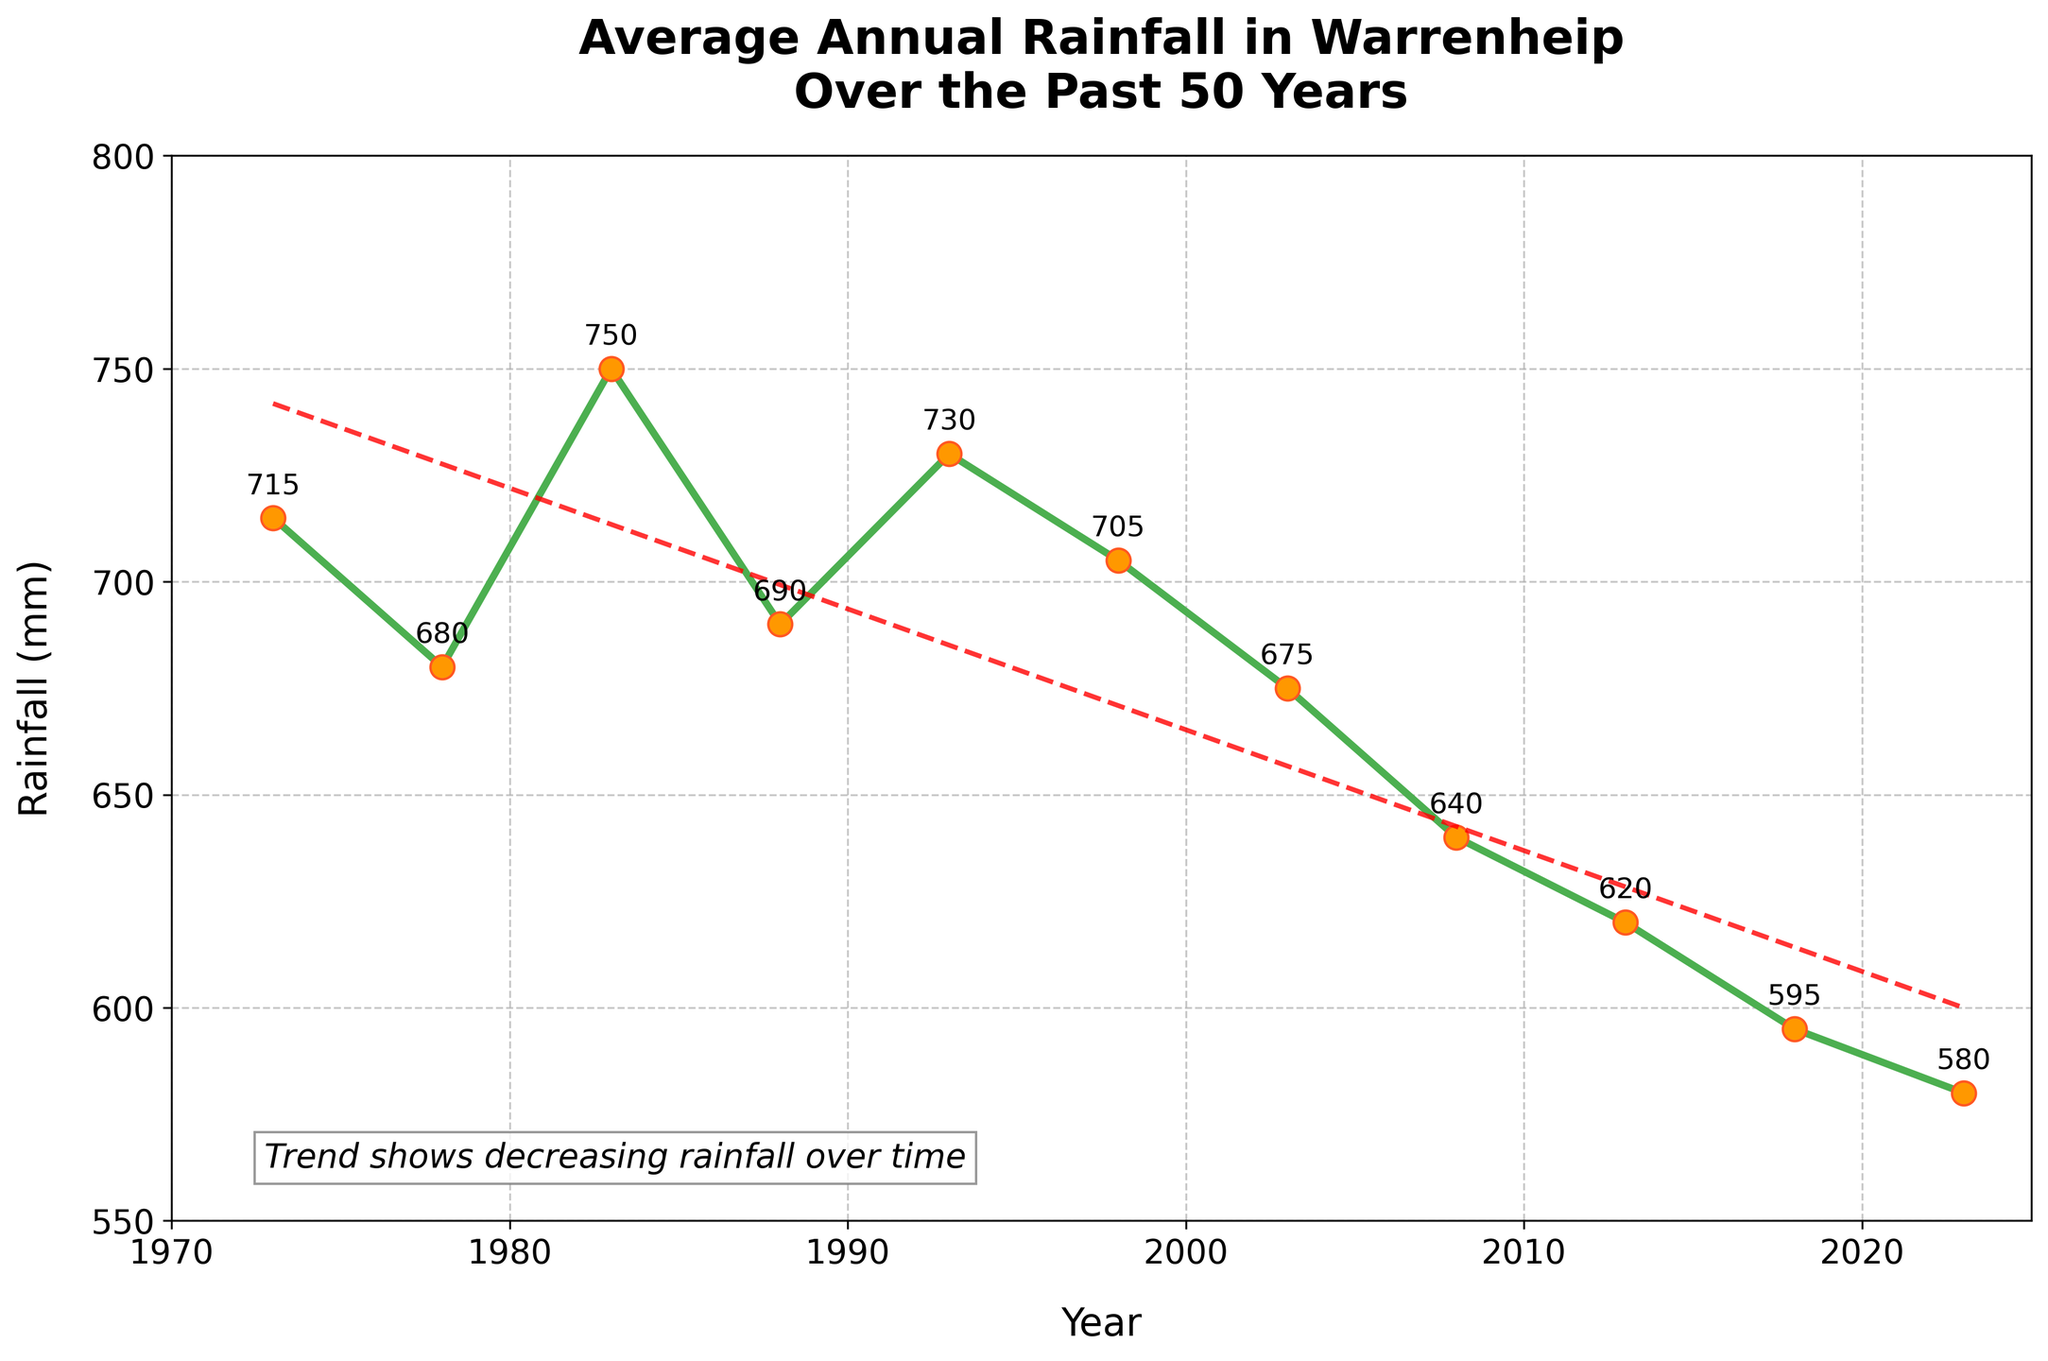What is the general trend of average annual rainfall in Warrenheip over the past 50 years? The plot shows a red dashed trend line that generally slopes downward from 1973 to 2023, indicating a decreasing trend in average annual rainfall.
Answer: Decreasing What is the highest recorded average annual rainfall in the dataset, and in which year was it observed? The highest point on the line plot is at 750 mm, which was recorded in the year 1983.
Answer: 750 mm in 1983 How much did the average annual rainfall decrease from 1973 to 2023? The rainfall in 1973 was 715 mm, and in 2023 it was 580 mm. The difference is 715 mm - 580 mm = 135 mm.
Answer: 135 mm Which year had the lowest average annual rainfall, and what was the value? The lowest point on the line plot is at 580 mm, which was recorded in the year 2023.
Answer: 580 mm in 2023 By how much did the average annual rainfall increase from 2013 to 2018? The rainfall in 2013 was 620 mm, and in 2018 it was 595 mm. The difference is 595 mm - 620 mm = -25 mm, indicating a decrease rather than an increase.
Answer: -25 mm (a decrease) What is the average annual rainfall over the last 50 years? There are 11 data points. Summing the values: 715 + 680 + 750 + 690 + 730 + 705 + 675 + 640 + 620 + 595 + 580 = 7380. Dividing by the number of data points: 7380 / 11 ≈ 670.91 mm.
Answer: 670.91 mm How does the average annual rainfall in 1993 compare to that in 1998? The rainfall in 1993 was 730 mm, and in 1998 it was 705 mm. Comparing them, 730 mm is greater than 705 mm.
Answer: 730 mm is greater What is the difference in average annual rainfall between the highest and lowest recorded years? The highest rainfall is 750 mm in 1983 and the lowest is 580 mm in 2023. The difference is 750 mm - 580 mm = 170 mm.
Answer: 170 mm How does the rainfall measurement in 2008 compare to the trend shown by the red dashed line? The rainfall in 2008 was 640 mm. The red dashed trend line is generally below this value in the years close to 2008, indicating that the 2008 rainfall was slightly above the trend line.
Answer: Slightly above the trend Identify two consecutive years where the average annual rainfall increased, and specify the increments. From 1978 (680 mm) to 1983 (750 mm), the rainfall increased by 750 mm - 680 mm = 70 mm. Also, from 1993 (730 mm) to 1998 (705 mm), there was actually a decrease, not an increase.
Answer: 1978 to 1983 by 70 mm 